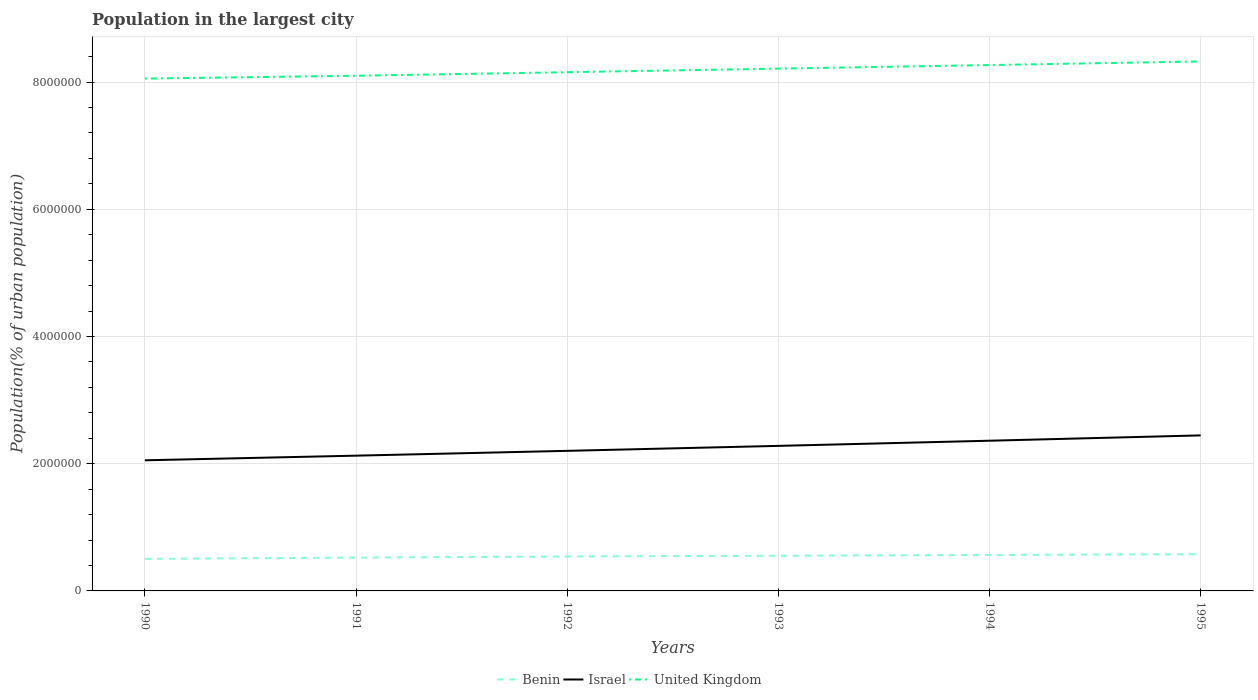Is the number of lines equal to the number of legend labels?
Keep it short and to the point. Yes. Across all years, what is the maximum population in the largest city in United Kingdom?
Your answer should be compact. 8.05e+06. What is the total population in the largest city in United Kingdom in the graph?
Make the answer very short. -1.13e+05. What is the difference between the highest and the second highest population in the largest city in Israel?
Provide a short and direct response. 3.92e+05. What is the difference between the highest and the lowest population in the largest city in United Kingdom?
Offer a very short reply. 3. Is the population in the largest city in Benin strictly greater than the population in the largest city in Israel over the years?
Your answer should be very brief. Yes. How many lines are there?
Offer a terse response. 3. What is the difference between two consecutive major ticks on the Y-axis?
Ensure brevity in your answer.  2.00e+06. Does the graph contain grids?
Your answer should be very brief. Yes. Where does the legend appear in the graph?
Give a very brief answer. Bottom center. How are the legend labels stacked?
Your answer should be very brief. Horizontal. What is the title of the graph?
Offer a very short reply. Population in the largest city. What is the label or title of the X-axis?
Your response must be concise. Years. What is the label or title of the Y-axis?
Keep it short and to the point. Population(% of urban population). What is the Population(% of urban population) in Benin in 1990?
Your answer should be compact. 5.04e+05. What is the Population(% of urban population) of Israel in 1990?
Offer a terse response. 2.05e+06. What is the Population(% of urban population) in United Kingdom in 1990?
Provide a succinct answer. 8.05e+06. What is the Population(% of urban population) of Benin in 1991?
Your answer should be very brief. 5.24e+05. What is the Population(% of urban population) in Israel in 1991?
Give a very brief answer. 2.13e+06. What is the Population(% of urban population) in United Kingdom in 1991?
Give a very brief answer. 8.10e+06. What is the Population(% of urban population) of Benin in 1992?
Offer a terse response. 5.42e+05. What is the Population(% of urban population) in Israel in 1992?
Your response must be concise. 2.20e+06. What is the Population(% of urban population) in United Kingdom in 1992?
Offer a terse response. 8.15e+06. What is the Population(% of urban population) of Benin in 1993?
Offer a very short reply. 5.53e+05. What is the Population(% of urban population) in Israel in 1993?
Offer a very short reply. 2.28e+06. What is the Population(% of urban population) of United Kingdom in 1993?
Ensure brevity in your answer.  8.21e+06. What is the Population(% of urban population) of Benin in 1994?
Keep it short and to the point. 5.65e+05. What is the Population(% of urban population) of Israel in 1994?
Ensure brevity in your answer.  2.36e+06. What is the Population(% of urban population) of United Kingdom in 1994?
Offer a very short reply. 8.27e+06. What is the Population(% of urban population) of Benin in 1995?
Offer a terse response. 5.77e+05. What is the Population(% of urban population) in Israel in 1995?
Ensure brevity in your answer.  2.44e+06. What is the Population(% of urban population) in United Kingdom in 1995?
Keep it short and to the point. 8.32e+06. Across all years, what is the maximum Population(% of urban population) of Benin?
Offer a very short reply. 5.77e+05. Across all years, what is the maximum Population(% of urban population) of Israel?
Offer a very short reply. 2.44e+06. Across all years, what is the maximum Population(% of urban population) of United Kingdom?
Make the answer very short. 8.32e+06. Across all years, what is the minimum Population(% of urban population) of Benin?
Your answer should be very brief. 5.04e+05. Across all years, what is the minimum Population(% of urban population) in Israel?
Give a very brief answer. 2.05e+06. Across all years, what is the minimum Population(% of urban population) of United Kingdom?
Make the answer very short. 8.05e+06. What is the total Population(% of urban population) of Benin in the graph?
Offer a terse response. 3.27e+06. What is the total Population(% of urban population) in Israel in the graph?
Provide a short and direct response. 1.35e+07. What is the total Population(% of urban population) of United Kingdom in the graph?
Offer a very short reply. 4.91e+07. What is the difference between the Population(% of urban population) of Benin in 1990 and that in 1991?
Keep it short and to the point. -2.06e+04. What is the difference between the Population(% of urban population) of Israel in 1990 and that in 1991?
Give a very brief answer. -7.30e+04. What is the difference between the Population(% of urban population) of United Kingdom in 1990 and that in 1991?
Give a very brief answer. -4.50e+04. What is the difference between the Population(% of urban population) in Benin in 1990 and that in 1992?
Make the answer very short. -3.79e+04. What is the difference between the Population(% of urban population) of Israel in 1990 and that in 1992?
Offer a terse response. -1.49e+05. What is the difference between the Population(% of urban population) in United Kingdom in 1990 and that in 1992?
Offer a very short reply. -1.01e+05. What is the difference between the Population(% of urban population) in Benin in 1990 and that in 1993?
Provide a succinct answer. -4.96e+04. What is the difference between the Population(% of urban population) of Israel in 1990 and that in 1993?
Give a very brief answer. -2.27e+05. What is the difference between the Population(% of urban population) of United Kingdom in 1990 and that in 1993?
Your answer should be compact. -1.57e+05. What is the difference between the Population(% of urban population) in Benin in 1990 and that in 1994?
Keep it short and to the point. -6.15e+04. What is the difference between the Population(% of urban population) of Israel in 1990 and that in 1994?
Your response must be concise. -3.08e+05. What is the difference between the Population(% of urban population) in United Kingdom in 1990 and that in 1994?
Your answer should be very brief. -2.13e+05. What is the difference between the Population(% of urban population) in Benin in 1990 and that in 1995?
Make the answer very short. -7.37e+04. What is the difference between the Population(% of urban population) of Israel in 1990 and that in 1995?
Make the answer very short. -3.92e+05. What is the difference between the Population(% of urban population) of United Kingdom in 1990 and that in 1995?
Your answer should be compact. -2.70e+05. What is the difference between the Population(% of urban population) in Benin in 1991 and that in 1992?
Ensure brevity in your answer.  -1.73e+04. What is the difference between the Population(% of urban population) of Israel in 1991 and that in 1992?
Offer a very short reply. -7.56e+04. What is the difference between the Population(% of urban population) in United Kingdom in 1991 and that in 1992?
Offer a very short reply. -5.57e+04. What is the difference between the Population(% of urban population) of Benin in 1991 and that in 1993?
Provide a succinct answer. -2.90e+04. What is the difference between the Population(% of urban population) in Israel in 1991 and that in 1993?
Provide a short and direct response. -1.54e+05. What is the difference between the Population(% of urban population) in United Kingdom in 1991 and that in 1993?
Offer a terse response. -1.12e+05. What is the difference between the Population(% of urban population) in Benin in 1991 and that in 1994?
Provide a succinct answer. -4.09e+04. What is the difference between the Population(% of urban population) in Israel in 1991 and that in 1994?
Your answer should be very brief. -2.35e+05. What is the difference between the Population(% of urban population) in United Kingdom in 1991 and that in 1994?
Keep it short and to the point. -1.68e+05. What is the difference between the Population(% of urban population) of Benin in 1991 and that in 1995?
Make the answer very short. -5.31e+04. What is the difference between the Population(% of urban population) of Israel in 1991 and that in 1995?
Provide a succinct answer. -3.19e+05. What is the difference between the Population(% of urban population) in United Kingdom in 1991 and that in 1995?
Offer a terse response. -2.25e+05. What is the difference between the Population(% of urban population) of Benin in 1992 and that in 1993?
Ensure brevity in your answer.  -1.17e+04. What is the difference between the Population(% of urban population) of Israel in 1992 and that in 1993?
Offer a terse response. -7.81e+04. What is the difference between the Population(% of urban population) in United Kingdom in 1992 and that in 1993?
Your answer should be very brief. -5.59e+04. What is the difference between the Population(% of urban population) in Benin in 1992 and that in 1994?
Your response must be concise. -2.36e+04. What is the difference between the Population(% of urban population) of Israel in 1992 and that in 1994?
Give a very brief answer. -1.59e+05. What is the difference between the Population(% of urban population) in United Kingdom in 1992 and that in 1994?
Provide a succinct answer. -1.12e+05. What is the difference between the Population(% of urban population) in Benin in 1992 and that in 1995?
Give a very brief answer. -3.58e+04. What is the difference between the Population(% of urban population) of Israel in 1992 and that in 1995?
Offer a terse response. -2.43e+05. What is the difference between the Population(% of urban population) in United Kingdom in 1992 and that in 1995?
Keep it short and to the point. -1.69e+05. What is the difference between the Population(% of urban population) in Benin in 1993 and that in 1994?
Give a very brief answer. -1.19e+04. What is the difference between the Population(% of urban population) of Israel in 1993 and that in 1994?
Offer a very short reply. -8.10e+04. What is the difference between the Population(% of urban population) of United Kingdom in 1993 and that in 1994?
Offer a very short reply. -5.63e+04. What is the difference between the Population(% of urban population) in Benin in 1993 and that in 1995?
Keep it short and to the point. -2.41e+04. What is the difference between the Population(% of urban population) in Israel in 1993 and that in 1995?
Provide a succinct answer. -1.65e+05. What is the difference between the Population(% of urban population) of United Kingdom in 1993 and that in 1995?
Your answer should be compact. -1.13e+05. What is the difference between the Population(% of urban population) of Benin in 1994 and that in 1995?
Your answer should be compact. -1.22e+04. What is the difference between the Population(% of urban population) in Israel in 1994 and that in 1995?
Your response must be concise. -8.39e+04. What is the difference between the Population(% of urban population) in United Kingdom in 1994 and that in 1995?
Ensure brevity in your answer.  -5.67e+04. What is the difference between the Population(% of urban population) of Benin in 1990 and the Population(% of urban population) of Israel in 1991?
Ensure brevity in your answer.  -1.62e+06. What is the difference between the Population(% of urban population) in Benin in 1990 and the Population(% of urban population) in United Kingdom in 1991?
Your answer should be very brief. -7.59e+06. What is the difference between the Population(% of urban population) of Israel in 1990 and the Population(% of urban population) of United Kingdom in 1991?
Your response must be concise. -6.05e+06. What is the difference between the Population(% of urban population) of Benin in 1990 and the Population(% of urban population) of Israel in 1992?
Make the answer very short. -1.70e+06. What is the difference between the Population(% of urban population) of Benin in 1990 and the Population(% of urban population) of United Kingdom in 1992?
Ensure brevity in your answer.  -7.65e+06. What is the difference between the Population(% of urban population) in Israel in 1990 and the Population(% of urban population) in United Kingdom in 1992?
Provide a short and direct response. -6.10e+06. What is the difference between the Population(% of urban population) of Benin in 1990 and the Population(% of urban population) of Israel in 1993?
Make the answer very short. -1.78e+06. What is the difference between the Population(% of urban population) in Benin in 1990 and the Population(% of urban population) in United Kingdom in 1993?
Keep it short and to the point. -7.71e+06. What is the difference between the Population(% of urban population) in Israel in 1990 and the Population(% of urban population) in United Kingdom in 1993?
Your response must be concise. -6.16e+06. What is the difference between the Population(% of urban population) in Benin in 1990 and the Population(% of urban population) in Israel in 1994?
Make the answer very short. -1.86e+06. What is the difference between the Population(% of urban population) of Benin in 1990 and the Population(% of urban population) of United Kingdom in 1994?
Keep it short and to the point. -7.76e+06. What is the difference between the Population(% of urban population) of Israel in 1990 and the Population(% of urban population) of United Kingdom in 1994?
Make the answer very short. -6.21e+06. What is the difference between the Population(% of urban population) in Benin in 1990 and the Population(% of urban population) in Israel in 1995?
Ensure brevity in your answer.  -1.94e+06. What is the difference between the Population(% of urban population) of Benin in 1990 and the Population(% of urban population) of United Kingdom in 1995?
Keep it short and to the point. -7.82e+06. What is the difference between the Population(% of urban population) of Israel in 1990 and the Population(% of urban population) of United Kingdom in 1995?
Make the answer very short. -6.27e+06. What is the difference between the Population(% of urban population) in Benin in 1991 and the Population(% of urban population) in Israel in 1992?
Provide a succinct answer. -1.68e+06. What is the difference between the Population(% of urban population) in Benin in 1991 and the Population(% of urban population) in United Kingdom in 1992?
Offer a very short reply. -7.63e+06. What is the difference between the Population(% of urban population) in Israel in 1991 and the Population(% of urban population) in United Kingdom in 1992?
Offer a very short reply. -6.03e+06. What is the difference between the Population(% of urban population) in Benin in 1991 and the Population(% of urban population) in Israel in 1993?
Keep it short and to the point. -1.76e+06. What is the difference between the Population(% of urban population) of Benin in 1991 and the Population(% of urban population) of United Kingdom in 1993?
Give a very brief answer. -7.69e+06. What is the difference between the Population(% of urban population) of Israel in 1991 and the Population(% of urban population) of United Kingdom in 1993?
Offer a terse response. -6.08e+06. What is the difference between the Population(% of urban population) of Benin in 1991 and the Population(% of urban population) of Israel in 1994?
Provide a short and direct response. -1.84e+06. What is the difference between the Population(% of urban population) in Benin in 1991 and the Population(% of urban population) in United Kingdom in 1994?
Your answer should be compact. -7.74e+06. What is the difference between the Population(% of urban population) in Israel in 1991 and the Population(% of urban population) in United Kingdom in 1994?
Give a very brief answer. -6.14e+06. What is the difference between the Population(% of urban population) of Benin in 1991 and the Population(% of urban population) of Israel in 1995?
Offer a terse response. -1.92e+06. What is the difference between the Population(% of urban population) of Benin in 1991 and the Population(% of urban population) of United Kingdom in 1995?
Offer a terse response. -7.80e+06. What is the difference between the Population(% of urban population) in Israel in 1991 and the Population(% of urban population) in United Kingdom in 1995?
Make the answer very short. -6.20e+06. What is the difference between the Population(% of urban population) in Benin in 1992 and the Population(% of urban population) in Israel in 1993?
Make the answer very short. -1.74e+06. What is the difference between the Population(% of urban population) of Benin in 1992 and the Population(% of urban population) of United Kingdom in 1993?
Your response must be concise. -7.67e+06. What is the difference between the Population(% of urban population) in Israel in 1992 and the Population(% of urban population) in United Kingdom in 1993?
Your answer should be compact. -6.01e+06. What is the difference between the Population(% of urban population) of Benin in 1992 and the Population(% of urban population) of Israel in 1994?
Your response must be concise. -1.82e+06. What is the difference between the Population(% of urban population) of Benin in 1992 and the Population(% of urban population) of United Kingdom in 1994?
Provide a succinct answer. -7.72e+06. What is the difference between the Population(% of urban population) in Israel in 1992 and the Population(% of urban population) in United Kingdom in 1994?
Offer a terse response. -6.06e+06. What is the difference between the Population(% of urban population) of Benin in 1992 and the Population(% of urban population) of Israel in 1995?
Your answer should be compact. -1.90e+06. What is the difference between the Population(% of urban population) in Benin in 1992 and the Population(% of urban population) in United Kingdom in 1995?
Make the answer very short. -7.78e+06. What is the difference between the Population(% of urban population) in Israel in 1992 and the Population(% of urban population) in United Kingdom in 1995?
Offer a terse response. -6.12e+06. What is the difference between the Population(% of urban population) in Benin in 1993 and the Population(% of urban population) in Israel in 1994?
Provide a succinct answer. -1.81e+06. What is the difference between the Population(% of urban population) of Benin in 1993 and the Population(% of urban population) of United Kingdom in 1994?
Offer a terse response. -7.71e+06. What is the difference between the Population(% of urban population) of Israel in 1993 and the Population(% of urban population) of United Kingdom in 1994?
Your answer should be very brief. -5.99e+06. What is the difference between the Population(% of urban population) of Benin in 1993 and the Population(% of urban population) of Israel in 1995?
Ensure brevity in your answer.  -1.89e+06. What is the difference between the Population(% of urban population) in Benin in 1993 and the Population(% of urban population) in United Kingdom in 1995?
Keep it short and to the point. -7.77e+06. What is the difference between the Population(% of urban population) of Israel in 1993 and the Population(% of urban population) of United Kingdom in 1995?
Provide a succinct answer. -6.04e+06. What is the difference between the Population(% of urban population) of Benin in 1994 and the Population(% of urban population) of Israel in 1995?
Keep it short and to the point. -1.88e+06. What is the difference between the Population(% of urban population) of Benin in 1994 and the Population(% of urban population) of United Kingdom in 1995?
Provide a succinct answer. -7.76e+06. What is the difference between the Population(% of urban population) of Israel in 1994 and the Population(% of urban population) of United Kingdom in 1995?
Offer a terse response. -5.96e+06. What is the average Population(% of urban population) of Benin per year?
Your answer should be compact. 5.44e+05. What is the average Population(% of urban population) of Israel per year?
Make the answer very short. 2.24e+06. What is the average Population(% of urban population) of United Kingdom per year?
Keep it short and to the point. 8.18e+06. In the year 1990, what is the difference between the Population(% of urban population) of Benin and Population(% of urban population) of Israel?
Your answer should be compact. -1.55e+06. In the year 1990, what is the difference between the Population(% of urban population) in Benin and Population(% of urban population) in United Kingdom?
Offer a very short reply. -7.55e+06. In the year 1990, what is the difference between the Population(% of urban population) of Israel and Population(% of urban population) of United Kingdom?
Provide a succinct answer. -6.00e+06. In the year 1991, what is the difference between the Population(% of urban population) in Benin and Population(% of urban population) in Israel?
Provide a succinct answer. -1.60e+06. In the year 1991, what is the difference between the Population(% of urban population) of Benin and Population(% of urban population) of United Kingdom?
Offer a very short reply. -7.57e+06. In the year 1991, what is the difference between the Population(% of urban population) of Israel and Population(% of urban population) of United Kingdom?
Provide a short and direct response. -5.97e+06. In the year 1992, what is the difference between the Population(% of urban population) of Benin and Population(% of urban population) of Israel?
Provide a succinct answer. -1.66e+06. In the year 1992, what is the difference between the Population(% of urban population) of Benin and Population(% of urban population) of United Kingdom?
Provide a succinct answer. -7.61e+06. In the year 1992, what is the difference between the Population(% of urban population) of Israel and Population(% of urban population) of United Kingdom?
Give a very brief answer. -5.95e+06. In the year 1993, what is the difference between the Population(% of urban population) in Benin and Population(% of urban population) in Israel?
Ensure brevity in your answer.  -1.73e+06. In the year 1993, what is the difference between the Population(% of urban population) in Benin and Population(% of urban population) in United Kingdom?
Your answer should be very brief. -7.66e+06. In the year 1993, what is the difference between the Population(% of urban population) of Israel and Population(% of urban population) of United Kingdom?
Give a very brief answer. -5.93e+06. In the year 1994, what is the difference between the Population(% of urban population) in Benin and Population(% of urban population) in Israel?
Your response must be concise. -1.80e+06. In the year 1994, what is the difference between the Population(% of urban population) in Benin and Population(% of urban population) in United Kingdom?
Keep it short and to the point. -7.70e+06. In the year 1994, what is the difference between the Population(% of urban population) of Israel and Population(% of urban population) of United Kingdom?
Your answer should be compact. -5.91e+06. In the year 1995, what is the difference between the Population(% of urban population) in Benin and Population(% of urban population) in Israel?
Your response must be concise. -1.87e+06. In the year 1995, what is the difference between the Population(% of urban population) in Benin and Population(% of urban population) in United Kingdom?
Make the answer very short. -7.75e+06. In the year 1995, what is the difference between the Population(% of urban population) in Israel and Population(% of urban population) in United Kingdom?
Make the answer very short. -5.88e+06. What is the ratio of the Population(% of urban population) of Benin in 1990 to that in 1991?
Provide a short and direct response. 0.96. What is the ratio of the Population(% of urban population) in Israel in 1990 to that in 1991?
Your response must be concise. 0.97. What is the ratio of the Population(% of urban population) of Israel in 1990 to that in 1992?
Ensure brevity in your answer.  0.93. What is the ratio of the Population(% of urban population) in United Kingdom in 1990 to that in 1992?
Your response must be concise. 0.99. What is the ratio of the Population(% of urban population) of Benin in 1990 to that in 1993?
Give a very brief answer. 0.91. What is the ratio of the Population(% of urban population) in Israel in 1990 to that in 1993?
Make the answer very short. 0.9. What is the ratio of the Population(% of urban population) of United Kingdom in 1990 to that in 1993?
Offer a very short reply. 0.98. What is the ratio of the Population(% of urban population) in Benin in 1990 to that in 1994?
Offer a very short reply. 0.89. What is the ratio of the Population(% of urban population) in Israel in 1990 to that in 1994?
Your answer should be compact. 0.87. What is the ratio of the Population(% of urban population) of United Kingdom in 1990 to that in 1994?
Offer a very short reply. 0.97. What is the ratio of the Population(% of urban population) in Benin in 1990 to that in 1995?
Provide a short and direct response. 0.87. What is the ratio of the Population(% of urban population) of Israel in 1990 to that in 1995?
Offer a very short reply. 0.84. What is the ratio of the Population(% of urban population) of United Kingdom in 1990 to that in 1995?
Offer a terse response. 0.97. What is the ratio of the Population(% of urban population) of Benin in 1991 to that in 1992?
Make the answer very short. 0.97. What is the ratio of the Population(% of urban population) of Israel in 1991 to that in 1992?
Offer a very short reply. 0.97. What is the ratio of the Population(% of urban population) of Benin in 1991 to that in 1993?
Make the answer very short. 0.95. What is the ratio of the Population(% of urban population) in Israel in 1991 to that in 1993?
Provide a succinct answer. 0.93. What is the ratio of the Population(% of urban population) in United Kingdom in 1991 to that in 1993?
Make the answer very short. 0.99. What is the ratio of the Population(% of urban population) of Benin in 1991 to that in 1994?
Give a very brief answer. 0.93. What is the ratio of the Population(% of urban population) of Israel in 1991 to that in 1994?
Offer a very short reply. 0.9. What is the ratio of the Population(% of urban population) of United Kingdom in 1991 to that in 1994?
Ensure brevity in your answer.  0.98. What is the ratio of the Population(% of urban population) of Benin in 1991 to that in 1995?
Ensure brevity in your answer.  0.91. What is the ratio of the Population(% of urban population) in Israel in 1991 to that in 1995?
Keep it short and to the point. 0.87. What is the ratio of the Population(% of urban population) of United Kingdom in 1991 to that in 1995?
Your answer should be compact. 0.97. What is the ratio of the Population(% of urban population) of Benin in 1992 to that in 1993?
Provide a short and direct response. 0.98. What is the ratio of the Population(% of urban population) in Israel in 1992 to that in 1993?
Your answer should be compact. 0.97. What is the ratio of the Population(% of urban population) in United Kingdom in 1992 to that in 1993?
Make the answer very short. 0.99. What is the ratio of the Population(% of urban population) in Benin in 1992 to that in 1994?
Keep it short and to the point. 0.96. What is the ratio of the Population(% of urban population) of Israel in 1992 to that in 1994?
Your answer should be very brief. 0.93. What is the ratio of the Population(% of urban population) in United Kingdom in 1992 to that in 1994?
Your response must be concise. 0.99. What is the ratio of the Population(% of urban population) in Benin in 1992 to that in 1995?
Give a very brief answer. 0.94. What is the ratio of the Population(% of urban population) of Israel in 1992 to that in 1995?
Offer a terse response. 0.9. What is the ratio of the Population(% of urban population) in United Kingdom in 1992 to that in 1995?
Provide a short and direct response. 0.98. What is the ratio of the Population(% of urban population) of Benin in 1993 to that in 1994?
Your answer should be very brief. 0.98. What is the ratio of the Population(% of urban population) of Israel in 1993 to that in 1994?
Keep it short and to the point. 0.97. What is the ratio of the Population(% of urban population) in United Kingdom in 1993 to that in 1994?
Your response must be concise. 0.99. What is the ratio of the Population(% of urban population) in Benin in 1993 to that in 1995?
Make the answer very short. 0.96. What is the ratio of the Population(% of urban population) in Israel in 1993 to that in 1995?
Offer a very short reply. 0.93. What is the ratio of the Population(% of urban population) of United Kingdom in 1993 to that in 1995?
Make the answer very short. 0.99. What is the ratio of the Population(% of urban population) of Benin in 1994 to that in 1995?
Your answer should be compact. 0.98. What is the ratio of the Population(% of urban population) in Israel in 1994 to that in 1995?
Ensure brevity in your answer.  0.97. What is the difference between the highest and the second highest Population(% of urban population) in Benin?
Your response must be concise. 1.22e+04. What is the difference between the highest and the second highest Population(% of urban population) of Israel?
Keep it short and to the point. 8.39e+04. What is the difference between the highest and the second highest Population(% of urban population) of United Kingdom?
Provide a short and direct response. 5.67e+04. What is the difference between the highest and the lowest Population(% of urban population) in Benin?
Offer a terse response. 7.37e+04. What is the difference between the highest and the lowest Population(% of urban population) in Israel?
Ensure brevity in your answer.  3.92e+05. What is the difference between the highest and the lowest Population(% of urban population) in United Kingdom?
Your answer should be very brief. 2.70e+05. 